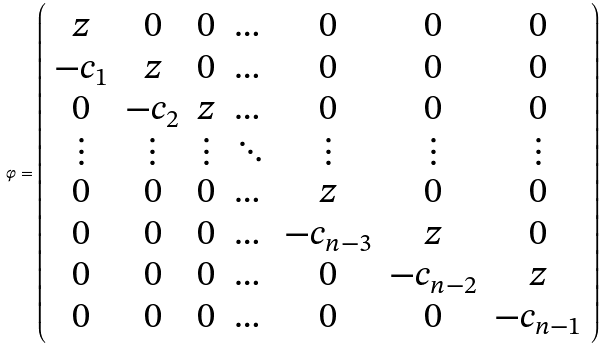Convert formula to latex. <formula><loc_0><loc_0><loc_500><loc_500>\varphi = \left ( \begin{array} { c c c c c c c c c c c } z & 0 & 0 & \dots & 0 & 0 & 0 \\ - c _ { 1 } & z & 0 & \dots & 0 & 0 & 0 \\ 0 & - c _ { 2 } & z & \dots & 0 & 0 & 0 \\ \vdots & \vdots & \vdots & \ddots & \vdots & \vdots & \vdots \\ 0 & 0 & 0 & \dots & z & 0 & 0 \\ 0 & 0 & 0 & \dots & - c _ { n - 3 } & z & 0 \\ 0 & 0 & 0 & \dots & 0 & - c _ { n - 2 } & z \\ 0 & 0 & 0 & \dots & 0 & 0 & - c _ { n - 1 } \end{array} \right )</formula> 